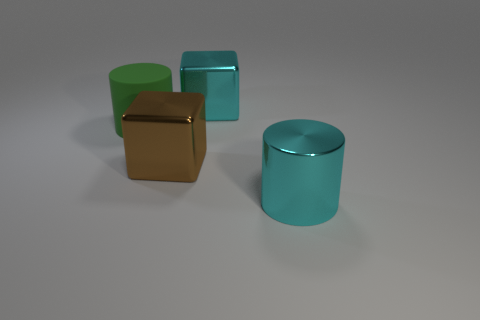Add 1 large brown metal things. How many objects exist? 5 Subtract 0 red cubes. How many objects are left? 4 Subtract all cyan rubber cubes. Subtract all large rubber cylinders. How many objects are left? 3 Add 4 large cubes. How many large cubes are left? 6 Add 4 cyan metal cubes. How many cyan metal cubes exist? 5 